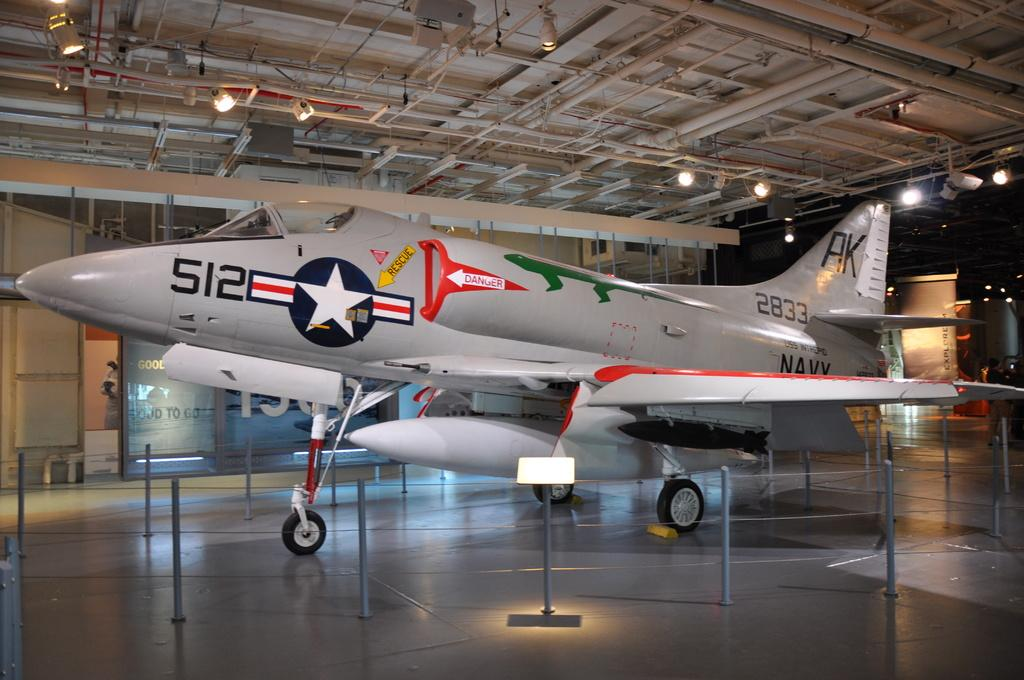Provide a one-sentence caption for the provided image. a plane in a museum with letters AK on the tail. 